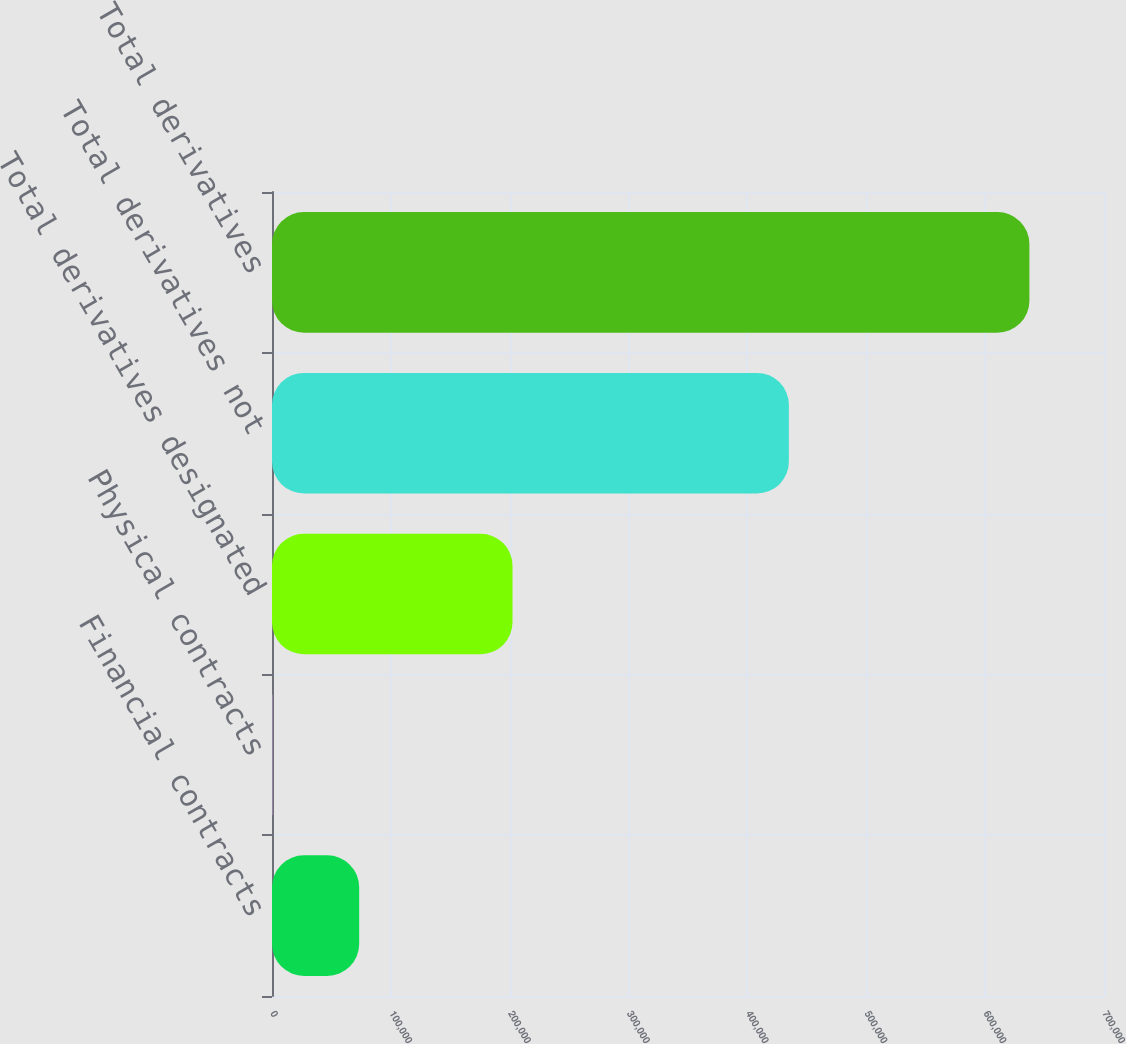Convert chart to OTSL. <chart><loc_0><loc_0><loc_500><loc_500><bar_chart><fcel>Financial contracts<fcel>Physical contracts<fcel>Total derivatives designated<fcel>Total derivatives not<fcel>Total derivatives<nl><fcel>73346<fcel>344<fcel>202356<fcel>434885<fcel>637241<nl></chart> 